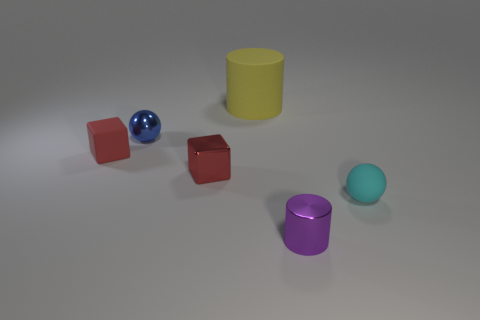Could you describe the spatial arrangement of the objects? Are there any patterns? The objects in the image seem to be arranged randomly with no discernible pattern. Starting from the left side of the image, there are two red cubes, followed by a blue shiny sphere, a yellow cylinder and a purple cylinder, and finally a cyan sphere on the extreme right. The positions do not conform to any recognizable geometric or symmetric pattern, and the spacing between the objects varies, which enhances the impression of a casual, possibly arbitrary layout. 